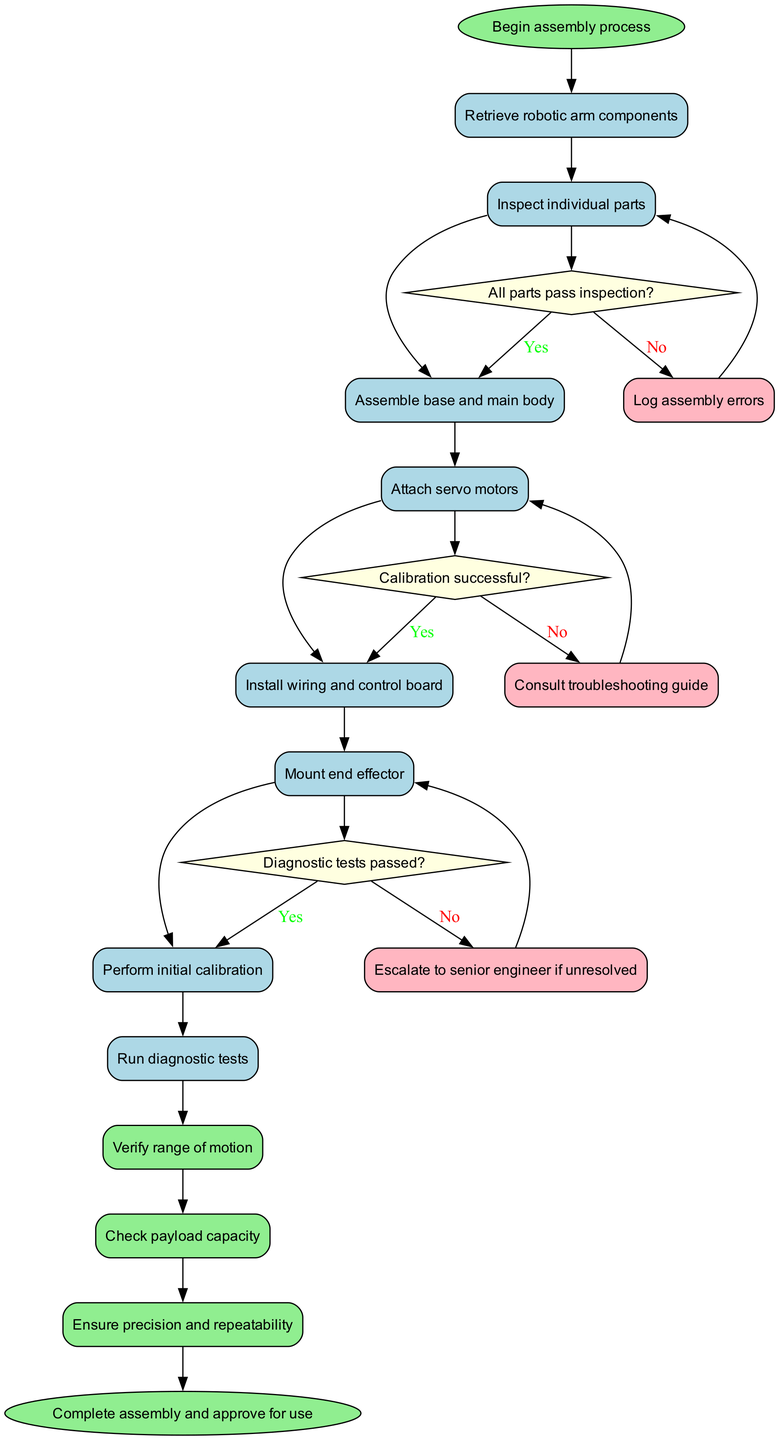What is the first activity in the assembly process? The diagram starts with the node labeled "Begin assembly process," which leads to the first activity, "Retrieve robotic arm components."
Answer: Retrieve robotic arm components How many decision nodes are there in the diagram? The diagram contains three decision nodes, each corresponding to inspection outcomes, calibration status, and diagnostic test results.
Answer: 3 What follows after "Run diagnostic tests"? The "Run diagnostic tests" activity leads to a decision node where it checks if the "Diagnostic tests passed?" each path diverges based on the test results.
Answer: "Diagnostic tests passed?" decision What happens if the calibration is unsuccessful? If the calibration is unsuccessful, the flow indicates a need to "Recalibrate," returning to the previous calibration activity to resolve the issue.
Answer: Recalibrate What is the last quality check performed? The last quality check is "Ensure precision and repeatability," which is the final activity before concluding the process.
Answer: Ensure precision and repeatability What does the error handling process involve if parts do not pass inspection? If parts do not pass inspection, it leads to the error handling activity "Request replacement parts," which aims to ensure only qualifying parts are used in assembly.
Answer: Request replacement parts How many total activities are depicted in the diagram? There are a total of eight activities detailed in the diagram, including the initial retrieval of components and various assembly and testing procedures.
Answer: 8 What is indicated if the diagnostic tests pass? If the diagnostic tests pass, the flow continues toward the final quality check process before completing the assembly.
Answer: Proceed to quality check 